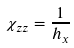Convert formula to latex. <formula><loc_0><loc_0><loc_500><loc_500>\chi _ { z z } = \frac { 1 } { h _ { x } }</formula> 